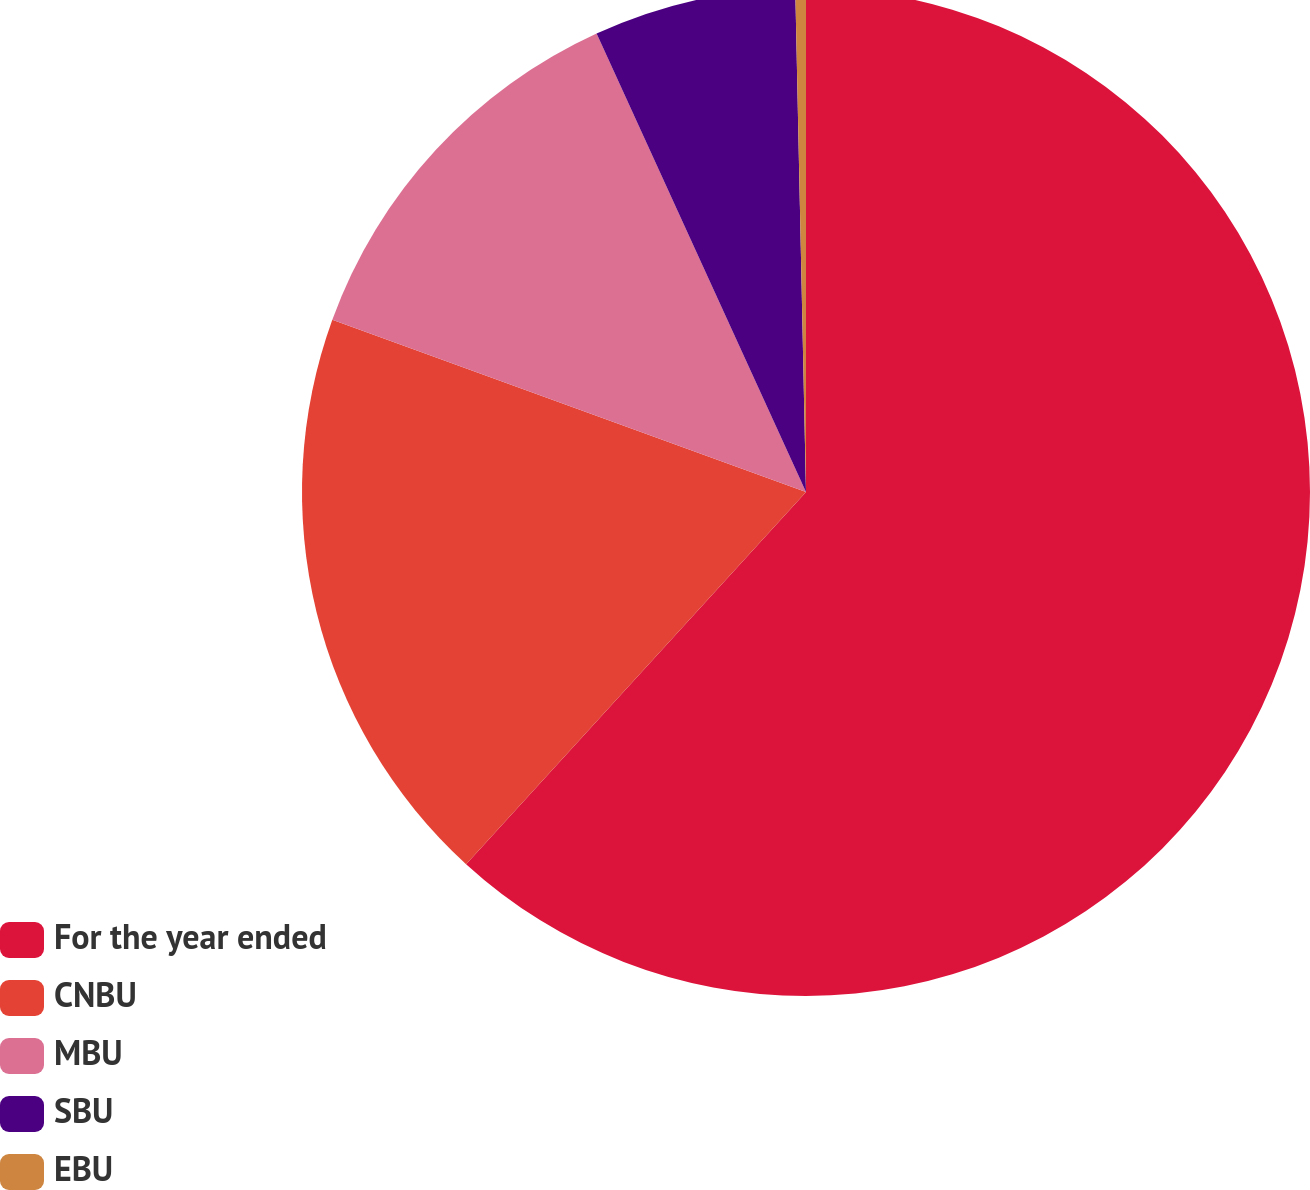<chart> <loc_0><loc_0><loc_500><loc_500><pie_chart><fcel>For the year ended<fcel>CNBU<fcel>MBU<fcel>SBU<fcel>EBU<nl><fcel>61.78%<fcel>18.77%<fcel>12.63%<fcel>6.48%<fcel>0.34%<nl></chart> 